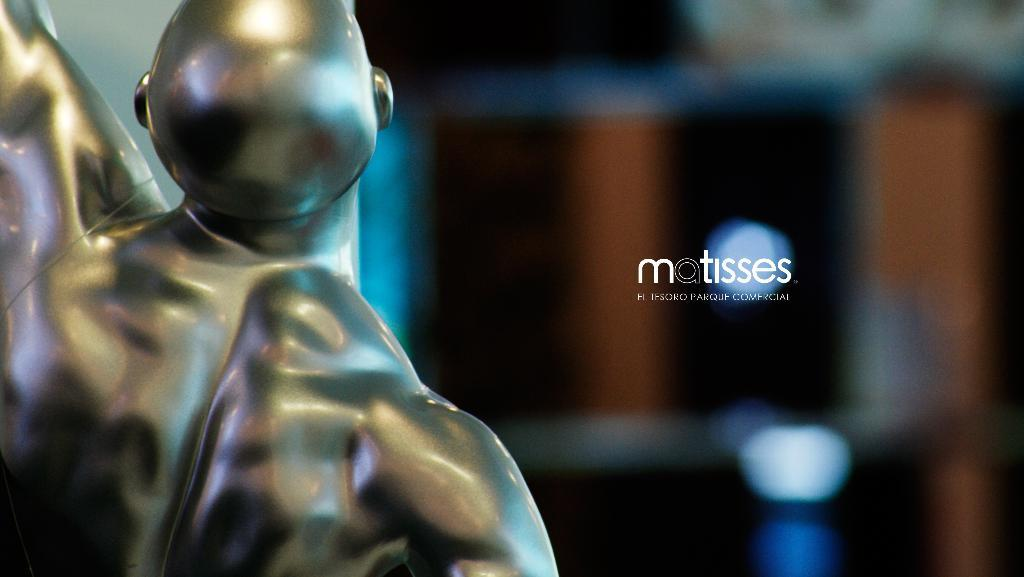What can be seen on the left side of the image? There is a sculpture on the left side of the image. What is the condition of the right side of the image? The right side of the image is blurred. What is present in the center of the image? There is a watermark in the center of the image. What type of machine is depicted in the image? There is no machine present in the image; it features a sculpture, a blurred right side, and a watermark. Can you tell me the language used in the watermark? The watermark is not legible due to its position in the image, so it is impossible to determine the language used. 